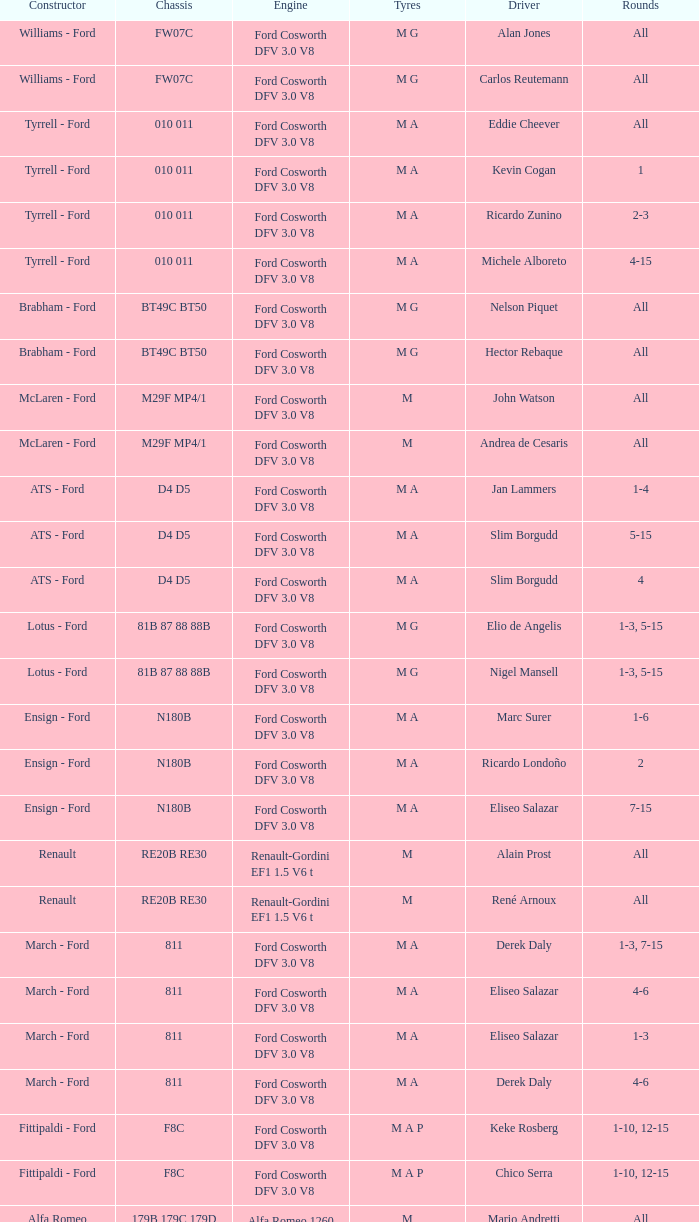Who constructed the car that Derek Warwick raced in with a TG181 chassis? Toleman - Hart. 